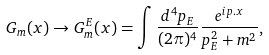<formula> <loc_0><loc_0><loc_500><loc_500>G _ { m } ( x ) \rightarrow G ^ { E } _ { m } ( x ) = \int \frac { d ^ { 4 } p _ { E } } { ( 2 \pi ) ^ { 4 } } \frac { e ^ { i p . x } } { p ^ { 2 } _ { E } + m ^ { 2 } } ,</formula> 